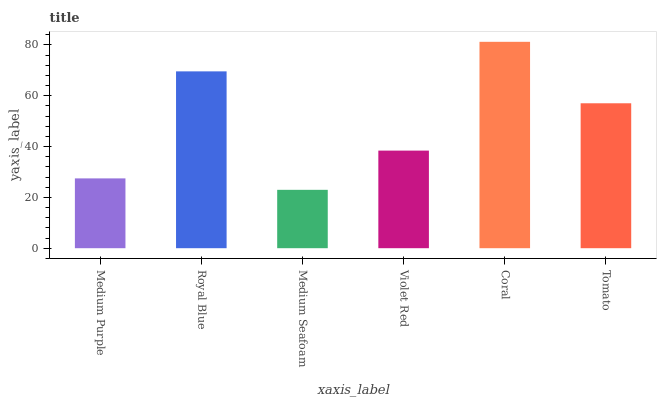Is Medium Seafoam the minimum?
Answer yes or no. Yes. Is Coral the maximum?
Answer yes or no. Yes. Is Royal Blue the minimum?
Answer yes or no. No. Is Royal Blue the maximum?
Answer yes or no. No. Is Royal Blue greater than Medium Purple?
Answer yes or no. Yes. Is Medium Purple less than Royal Blue?
Answer yes or no. Yes. Is Medium Purple greater than Royal Blue?
Answer yes or no. No. Is Royal Blue less than Medium Purple?
Answer yes or no. No. Is Tomato the high median?
Answer yes or no. Yes. Is Violet Red the low median?
Answer yes or no. Yes. Is Royal Blue the high median?
Answer yes or no. No. Is Royal Blue the low median?
Answer yes or no. No. 